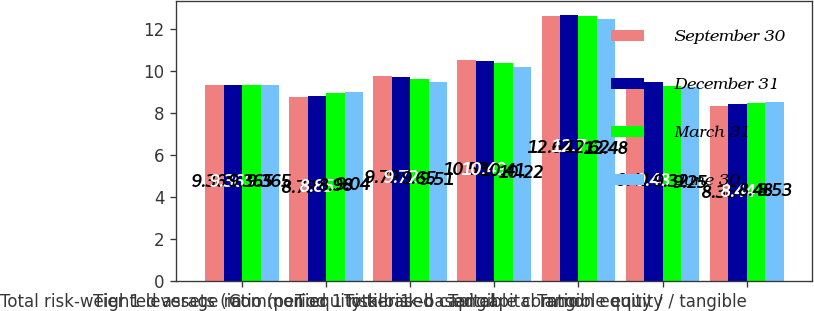Convert chart to OTSL. <chart><loc_0><loc_0><loc_500><loc_500><stacked_bar_chart><ecel><fcel>Total risk-weighted assets (in<fcel>Tier 1 leverage ratio (period<fcel>Common equity tier 1<fcel>Tier 1 risk-based capital<fcel>Total risk-based capital ratio<fcel>Tangible common equity /<fcel>Tangible equity / tangible<nl><fcel>September 30<fcel>9.365<fcel>8.79<fcel>9.79<fcel>10.53<fcel>12.64<fcel>9.41<fcel>8.36<nl><fcel>December 31<fcel>9.365<fcel>8.85<fcel>9.72<fcel>10.49<fcel>12.7<fcel>9.48<fcel>8.44<nl><fcel>March 31<fcel>9.365<fcel>8.98<fcel>9.65<fcel>10.41<fcel>12.62<fcel>9.32<fcel>8.48<nl><fcel>June 30<fcel>9.365<fcel>9.04<fcel>9.51<fcel>10.22<fcel>12.48<fcel>9.25<fcel>8.53<nl></chart> 